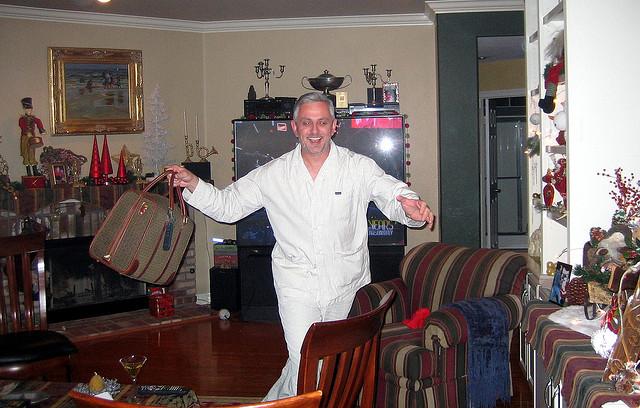What color is the man?
Write a very short answer. White. What color is this man's robe?
Give a very brief answer. White. What holiday is the room decorated for?
Answer briefly. Christmas. 